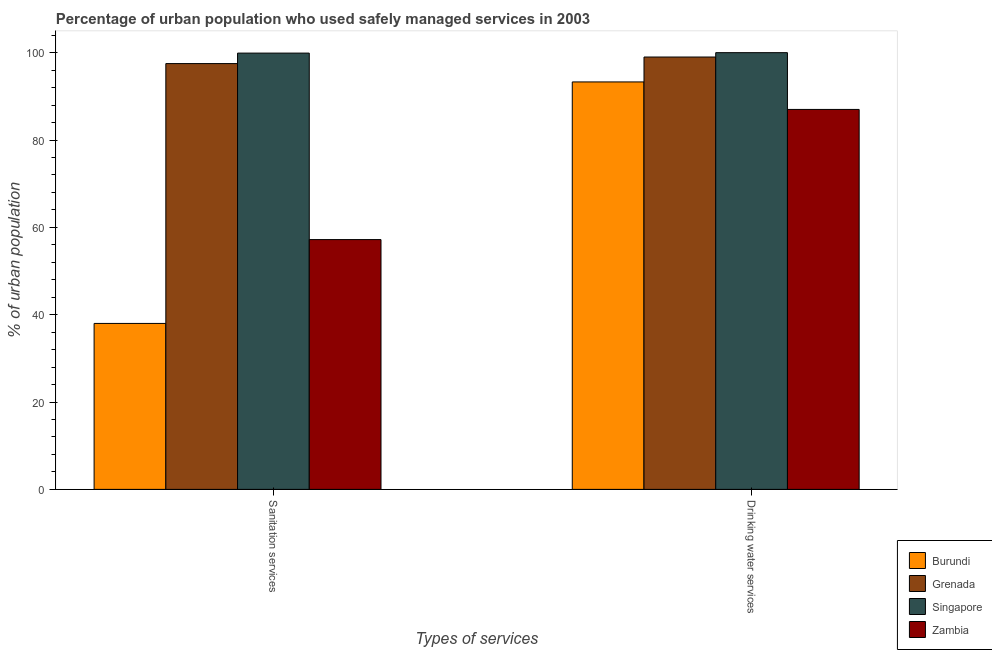How many different coloured bars are there?
Give a very brief answer. 4. Are the number of bars per tick equal to the number of legend labels?
Ensure brevity in your answer.  Yes. How many bars are there on the 2nd tick from the left?
Offer a terse response. 4. How many bars are there on the 1st tick from the right?
Provide a short and direct response. 4. What is the label of the 1st group of bars from the left?
Ensure brevity in your answer.  Sanitation services. What is the percentage of urban population who used sanitation services in Burundi?
Give a very brief answer. 38. In which country was the percentage of urban population who used drinking water services maximum?
Keep it short and to the point. Singapore. In which country was the percentage of urban population who used drinking water services minimum?
Offer a terse response. Zambia. What is the total percentage of urban population who used sanitation services in the graph?
Ensure brevity in your answer.  292.6. What is the difference between the percentage of urban population who used sanitation services in Singapore and that in Burundi?
Give a very brief answer. 61.9. What is the difference between the percentage of urban population who used drinking water services in Burundi and the percentage of urban population who used sanitation services in Singapore?
Make the answer very short. -6.6. What is the average percentage of urban population who used sanitation services per country?
Offer a very short reply. 73.15. What is the difference between the percentage of urban population who used sanitation services and percentage of urban population who used drinking water services in Burundi?
Your response must be concise. -55.3. In how many countries, is the percentage of urban population who used sanitation services greater than 60 %?
Your answer should be compact. 2. What is the ratio of the percentage of urban population who used drinking water services in Singapore to that in Burundi?
Your answer should be very brief. 1.07. What does the 1st bar from the left in Sanitation services represents?
Provide a short and direct response. Burundi. What does the 3rd bar from the right in Drinking water services represents?
Offer a very short reply. Grenada. Are all the bars in the graph horizontal?
Offer a terse response. No. Are the values on the major ticks of Y-axis written in scientific E-notation?
Provide a short and direct response. No. Does the graph contain any zero values?
Ensure brevity in your answer.  No. How many legend labels are there?
Your answer should be very brief. 4. How are the legend labels stacked?
Your response must be concise. Vertical. What is the title of the graph?
Give a very brief answer. Percentage of urban population who used safely managed services in 2003. Does "Norway" appear as one of the legend labels in the graph?
Give a very brief answer. No. What is the label or title of the X-axis?
Offer a terse response. Types of services. What is the label or title of the Y-axis?
Provide a succinct answer. % of urban population. What is the % of urban population of Burundi in Sanitation services?
Make the answer very short. 38. What is the % of urban population of Grenada in Sanitation services?
Your answer should be compact. 97.5. What is the % of urban population of Singapore in Sanitation services?
Give a very brief answer. 99.9. What is the % of urban population of Zambia in Sanitation services?
Provide a short and direct response. 57.2. What is the % of urban population of Burundi in Drinking water services?
Your answer should be very brief. 93.3. Across all Types of services, what is the maximum % of urban population in Burundi?
Provide a short and direct response. 93.3. Across all Types of services, what is the maximum % of urban population of Grenada?
Offer a very short reply. 99. Across all Types of services, what is the maximum % of urban population of Zambia?
Your answer should be compact. 87. Across all Types of services, what is the minimum % of urban population in Burundi?
Provide a short and direct response. 38. Across all Types of services, what is the minimum % of urban population of Grenada?
Keep it short and to the point. 97.5. Across all Types of services, what is the minimum % of urban population in Singapore?
Ensure brevity in your answer.  99.9. Across all Types of services, what is the minimum % of urban population in Zambia?
Your response must be concise. 57.2. What is the total % of urban population in Burundi in the graph?
Your response must be concise. 131.3. What is the total % of urban population of Grenada in the graph?
Your answer should be compact. 196.5. What is the total % of urban population in Singapore in the graph?
Provide a succinct answer. 199.9. What is the total % of urban population of Zambia in the graph?
Offer a very short reply. 144.2. What is the difference between the % of urban population in Burundi in Sanitation services and that in Drinking water services?
Offer a terse response. -55.3. What is the difference between the % of urban population of Grenada in Sanitation services and that in Drinking water services?
Make the answer very short. -1.5. What is the difference between the % of urban population in Singapore in Sanitation services and that in Drinking water services?
Make the answer very short. -0.1. What is the difference between the % of urban population in Zambia in Sanitation services and that in Drinking water services?
Offer a very short reply. -29.8. What is the difference between the % of urban population of Burundi in Sanitation services and the % of urban population of Grenada in Drinking water services?
Your response must be concise. -61. What is the difference between the % of urban population in Burundi in Sanitation services and the % of urban population in Singapore in Drinking water services?
Keep it short and to the point. -62. What is the difference between the % of urban population of Burundi in Sanitation services and the % of urban population of Zambia in Drinking water services?
Your response must be concise. -49. What is the difference between the % of urban population in Singapore in Sanitation services and the % of urban population in Zambia in Drinking water services?
Provide a succinct answer. 12.9. What is the average % of urban population in Burundi per Types of services?
Ensure brevity in your answer.  65.65. What is the average % of urban population of Grenada per Types of services?
Your answer should be compact. 98.25. What is the average % of urban population of Singapore per Types of services?
Offer a very short reply. 99.95. What is the average % of urban population in Zambia per Types of services?
Offer a terse response. 72.1. What is the difference between the % of urban population in Burundi and % of urban population in Grenada in Sanitation services?
Ensure brevity in your answer.  -59.5. What is the difference between the % of urban population of Burundi and % of urban population of Singapore in Sanitation services?
Make the answer very short. -61.9. What is the difference between the % of urban population of Burundi and % of urban population of Zambia in Sanitation services?
Ensure brevity in your answer.  -19.2. What is the difference between the % of urban population of Grenada and % of urban population of Singapore in Sanitation services?
Make the answer very short. -2.4. What is the difference between the % of urban population in Grenada and % of urban population in Zambia in Sanitation services?
Provide a short and direct response. 40.3. What is the difference between the % of urban population in Singapore and % of urban population in Zambia in Sanitation services?
Keep it short and to the point. 42.7. What is the difference between the % of urban population in Burundi and % of urban population in Grenada in Drinking water services?
Offer a terse response. -5.7. What is the difference between the % of urban population of Burundi and % of urban population of Singapore in Drinking water services?
Make the answer very short. -6.7. What is the difference between the % of urban population of Burundi and % of urban population of Zambia in Drinking water services?
Ensure brevity in your answer.  6.3. What is the difference between the % of urban population in Singapore and % of urban population in Zambia in Drinking water services?
Your answer should be compact. 13. What is the ratio of the % of urban population of Burundi in Sanitation services to that in Drinking water services?
Offer a terse response. 0.41. What is the ratio of the % of urban population of Grenada in Sanitation services to that in Drinking water services?
Offer a very short reply. 0.98. What is the ratio of the % of urban population in Zambia in Sanitation services to that in Drinking water services?
Make the answer very short. 0.66. What is the difference between the highest and the second highest % of urban population of Burundi?
Make the answer very short. 55.3. What is the difference between the highest and the second highest % of urban population of Grenada?
Give a very brief answer. 1.5. What is the difference between the highest and the second highest % of urban population in Zambia?
Offer a terse response. 29.8. What is the difference between the highest and the lowest % of urban population in Burundi?
Your answer should be very brief. 55.3. What is the difference between the highest and the lowest % of urban population of Zambia?
Offer a terse response. 29.8. 